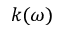Convert formula to latex. <formula><loc_0><loc_0><loc_500><loc_500>k ( \omega )</formula> 